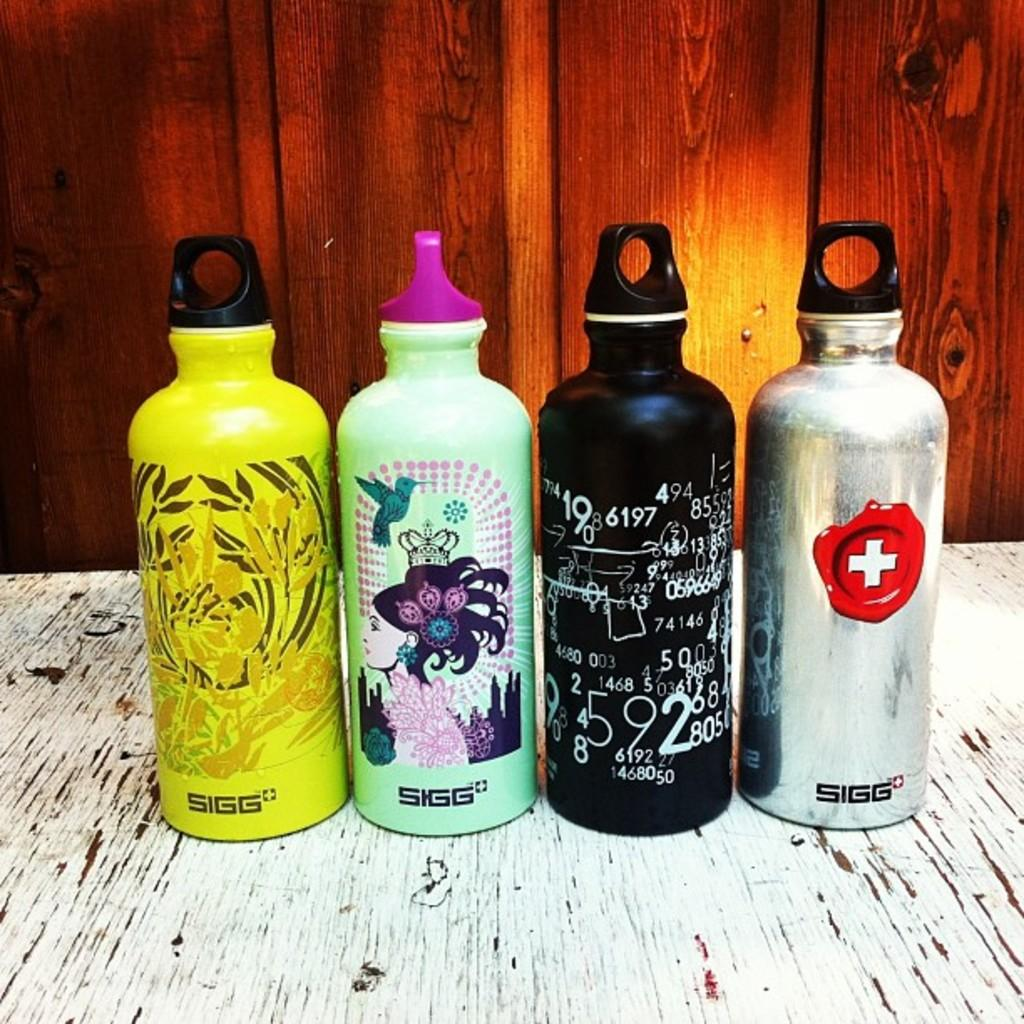Provide a one-sentence caption for the provided image. Four SIGG water bottles side by side on a table. 